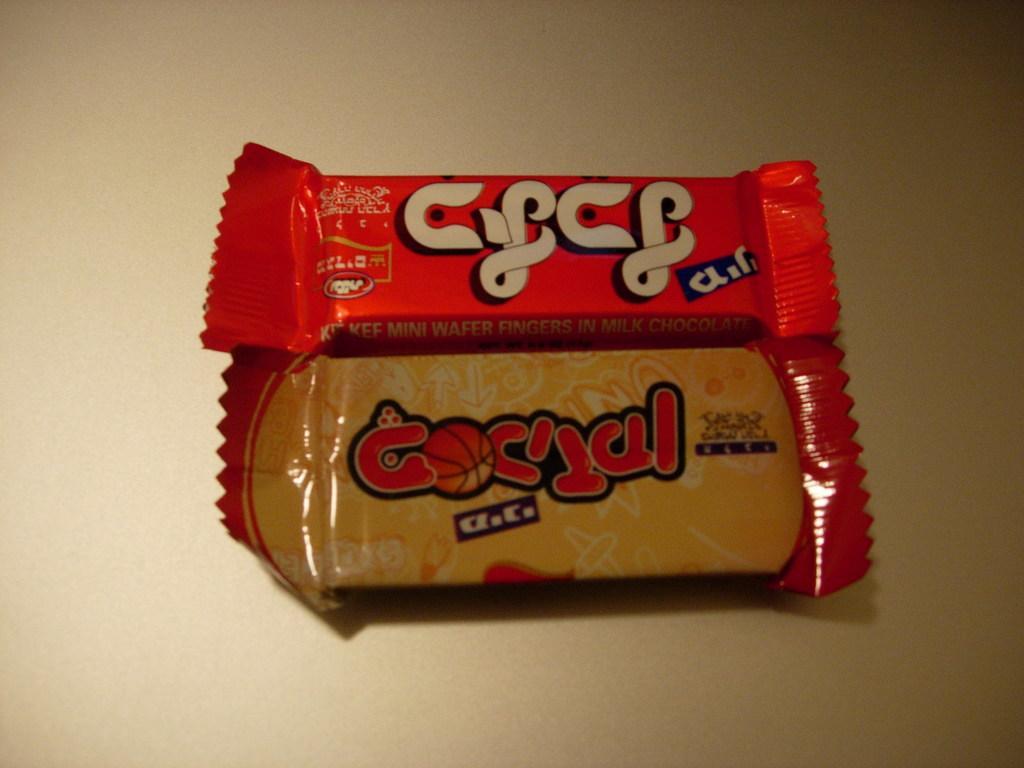In one or two sentences, can you explain what this image depicts? In this image I can see the chocolates on the cream background. 